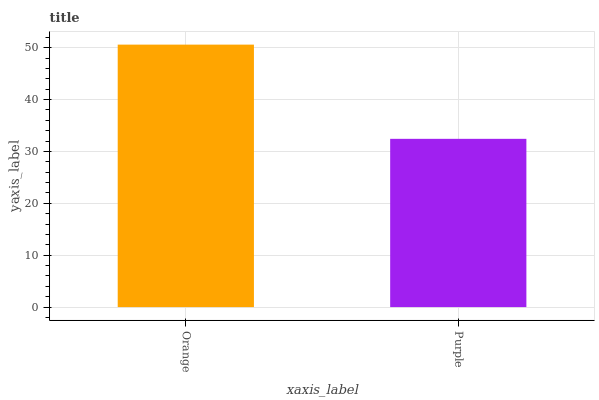Is Purple the minimum?
Answer yes or no. Yes. Is Orange the maximum?
Answer yes or no. Yes. Is Purple the maximum?
Answer yes or no. No. Is Orange greater than Purple?
Answer yes or no. Yes. Is Purple less than Orange?
Answer yes or no. Yes. Is Purple greater than Orange?
Answer yes or no. No. Is Orange less than Purple?
Answer yes or no. No. Is Orange the high median?
Answer yes or no. Yes. Is Purple the low median?
Answer yes or no. Yes. Is Purple the high median?
Answer yes or no. No. Is Orange the low median?
Answer yes or no. No. 